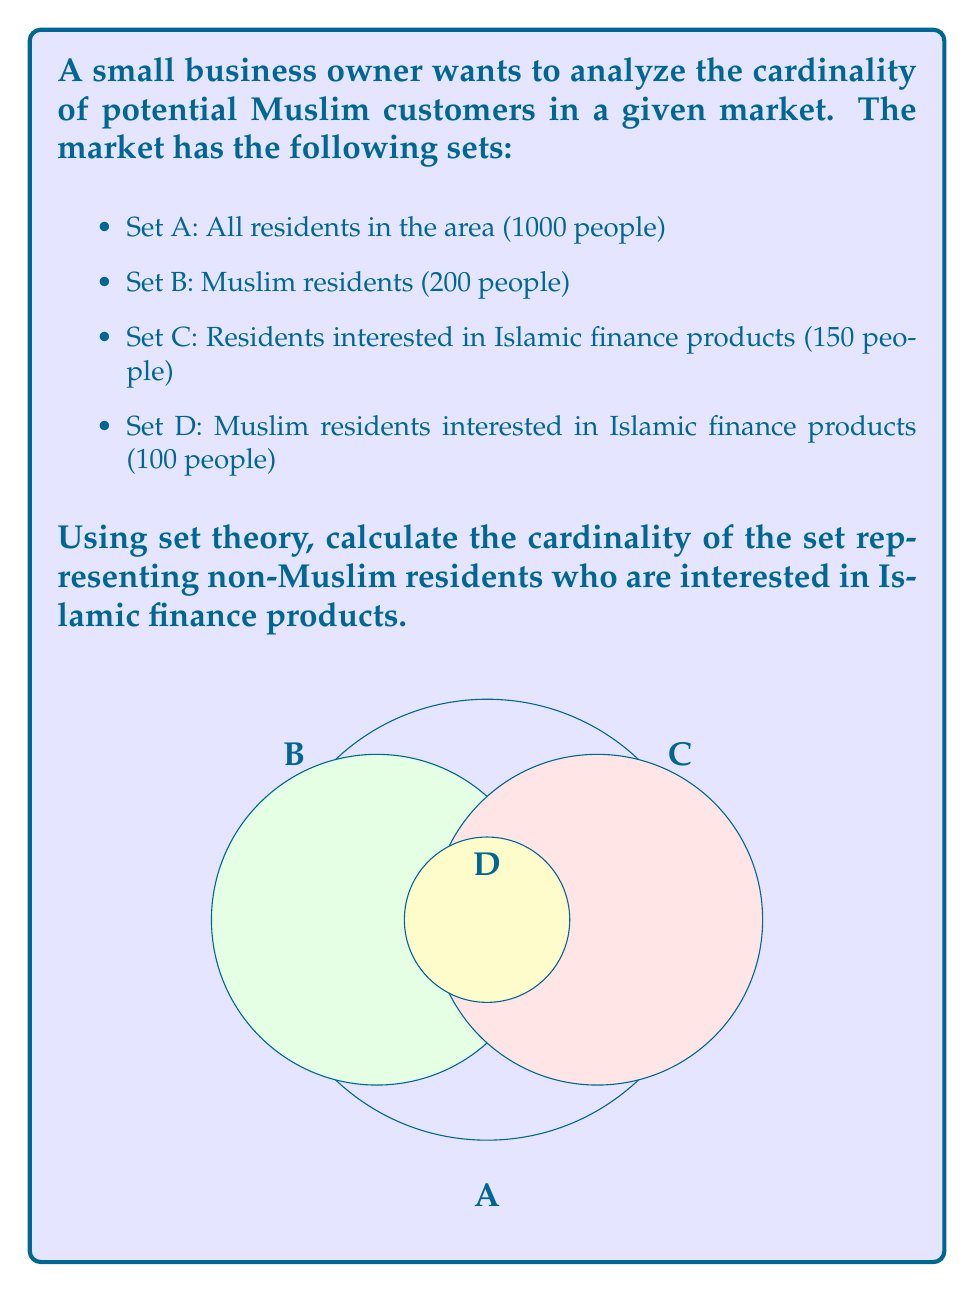Teach me how to tackle this problem. Let's approach this step-by-step using set theory:

1) First, let's define our sets:
   A = All residents
   B = Muslim residents
   C = Residents interested in Islamic finance products
   D = Muslim residents interested in Islamic finance products

2) We're looking for non-Muslim residents interested in Islamic finance products. This can be represented as:
   $C \setminus D$

3) To find the cardinality of this set, we can use the principle of inclusion-exclusion:
   $|C \setminus D| = |C| - |D|$

4) We're given:
   $|C| = 150$
   $|D| = 100$

5) Plugging these values into our equation:
   $|C \setminus D| = 150 - 100 = 50$

Therefore, there are 50 non-Muslim residents who are interested in Islamic finance products.

This result makes sense in the context of Islamic finance and the business owner's interests. It shows there's a potential market segment of non-Muslim customers interested in Islamic finance products, which could be an opportunity for expanding the business's customer base beyond the traditional Muslim market.
Answer: $|C \setminus D| = 50$ 